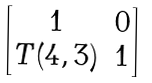<formula> <loc_0><loc_0><loc_500><loc_500>\begin{bmatrix} 1 & 0 \\ T ( 4 , 3 ) & 1 \end{bmatrix}</formula> 